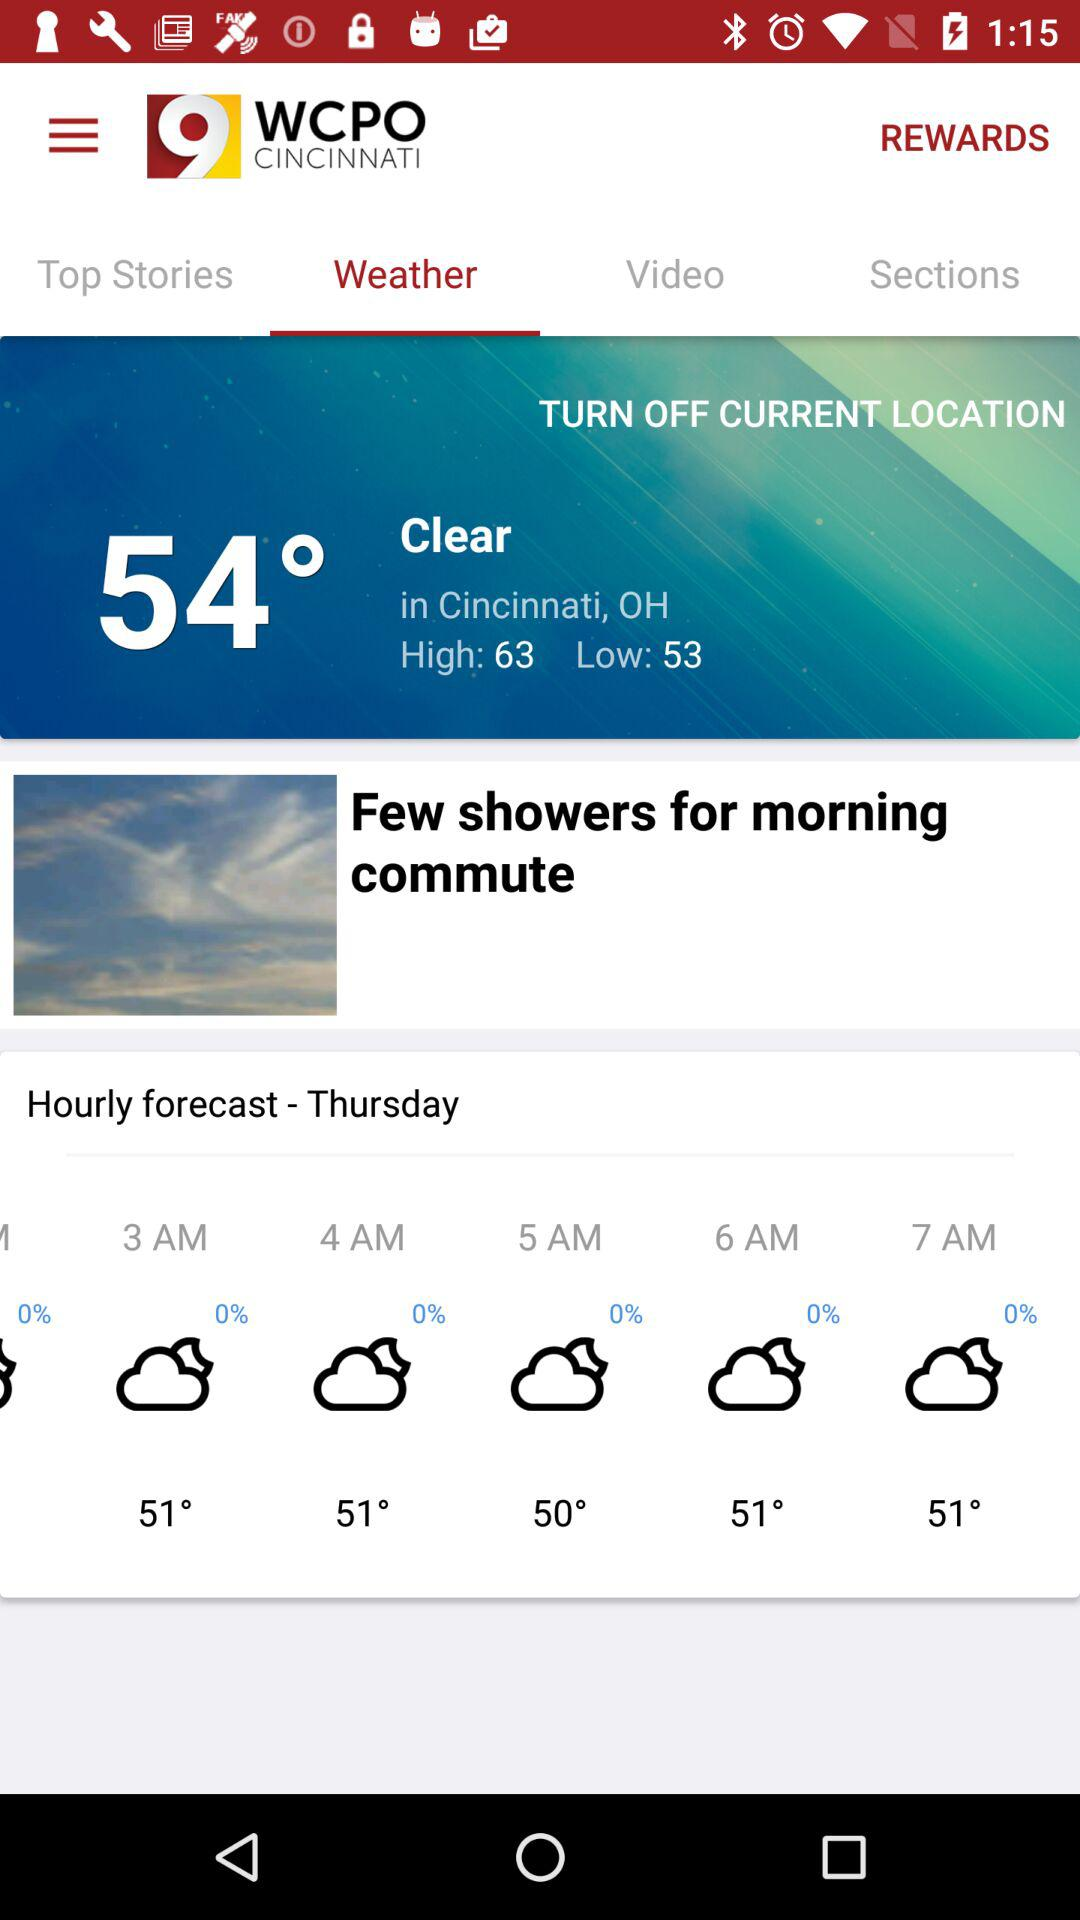How many degrees warmer is the high temperature than the low temperature?
Answer the question using a single word or phrase. 10 